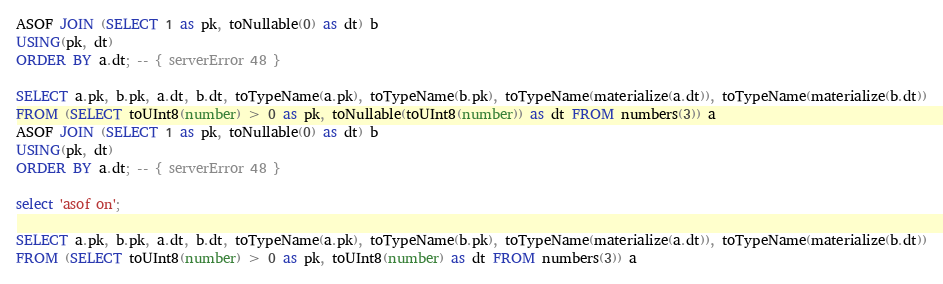<code> <loc_0><loc_0><loc_500><loc_500><_SQL_>ASOF JOIN (SELECT 1 as pk, toNullable(0) as dt) b
USING(pk, dt)
ORDER BY a.dt; -- { serverError 48 }

SELECT a.pk, b.pk, a.dt, b.dt, toTypeName(a.pk), toTypeName(b.pk), toTypeName(materialize(a.dt)), toTypeName(materialize(b.dt))
FROM (SELECT toUInt8(number) > 0 as pk, toNullable(toUInt8(number)) as dt FROM numbers(3)) a
ASOF JOIN (SELECT 1 as pk, toNullable(0) as dt) b
USING(pk, dt)
ORDER BY a.dt; -- { serverError 48 }

select 'asof on';

SELECT a.pk, b.pk, a.dt, b.dt, toTypeName(a.pk), toTypeName(b.pk), toTypeName(materialize(a.dt)), toTypeName(materialize(b.dt))
FROM (SELECT toUInt8(number) > 0 as pk, toUInt8(number) as dt FROM numbers(3)) a</code> 